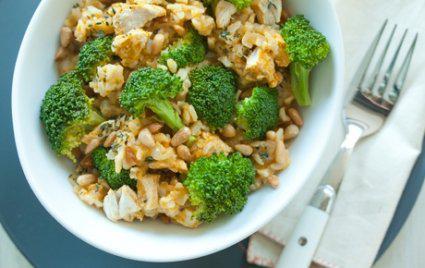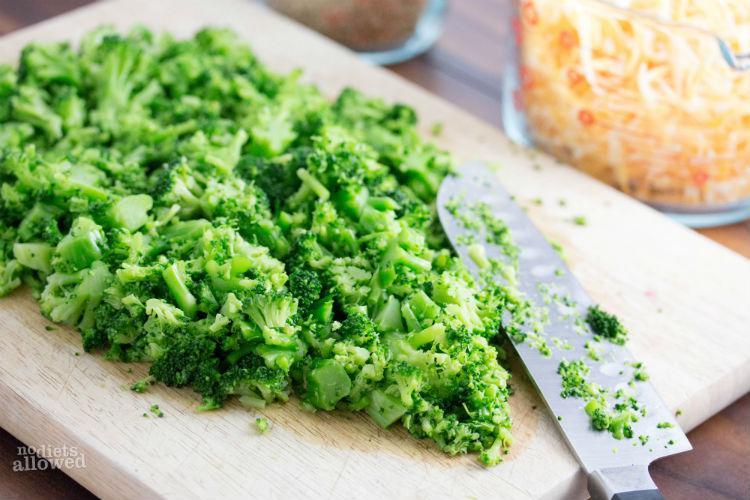The first image is the image on the left, the second image is the image on the right. Analyze the images presented: Is the assertion "One image features whole broccoli pieces in a bowl." valid? Answer yes or no. Yes. 